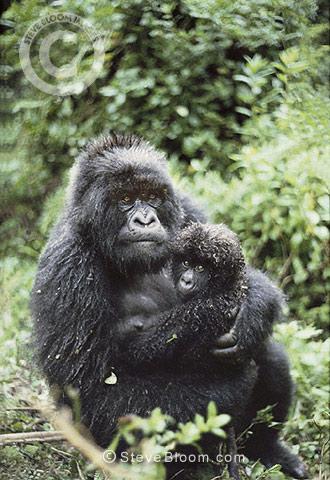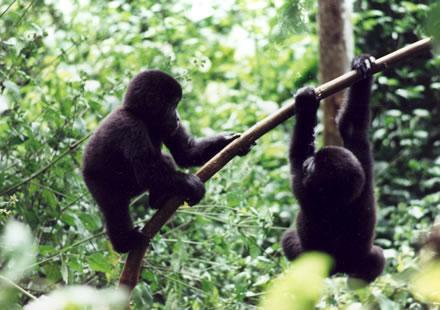The first image is the image on the left, the second image is the image on the right. Evaluate the accuracy of this statement regarding the images: "An image shows two gorillas of similar size posed close together, with bodies facing each other.". Is it true? Answer yes or no. No. The first image is the image on the left, the second image is the image on the right. Assess this claim about the two images: "There are four gorillas with two pairs touching one another.". Correct or not? Answer yes or no. No. 